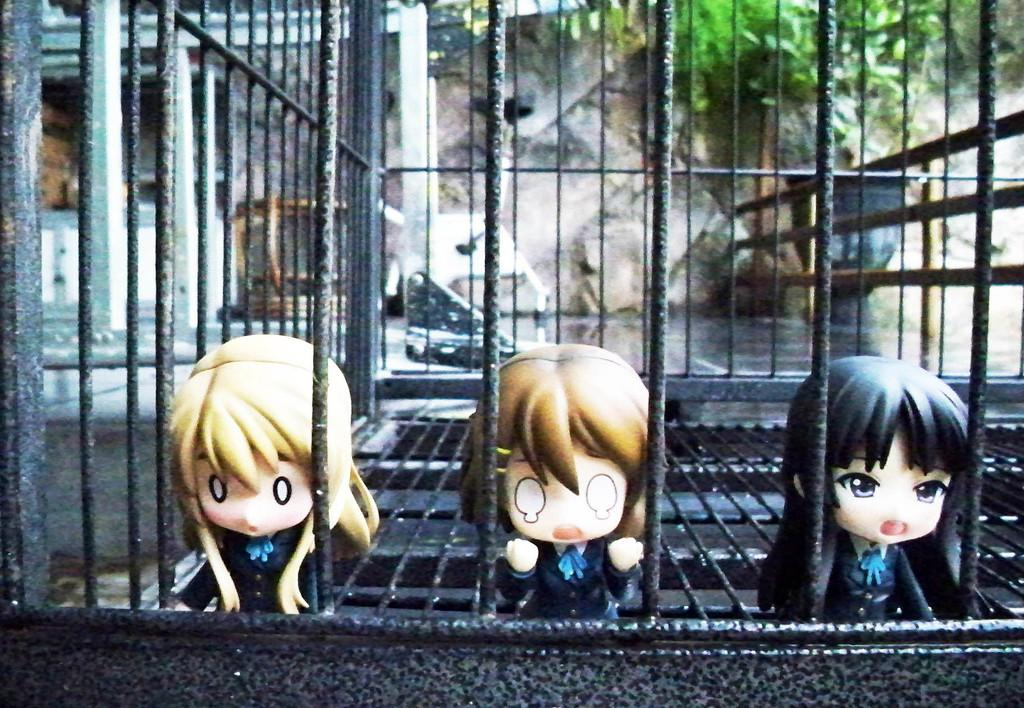What is contained within the cage in the image? There are toys in a cage in the image. What is at the bottom of the image? There is a carpet at the bottom of the image. What can be seen in the background of the image? There is a wall, a tree, and a black color object in the background of the image. How does the eye in the image breathe? There is no eye present in the image; it only contains toys in a cage, a carpet, and objects in the background. 